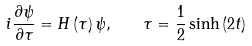Convert formula to latex. <formula><loc_0><loc_0><loc_500><loc_500>i \frac { \partial \psi } { \partial \tau } = H \left ( \tau \right ) \psi , \quad \tau = \frac { 1 } { 2 } \sinh \left ( 2 t \right )</formula> 